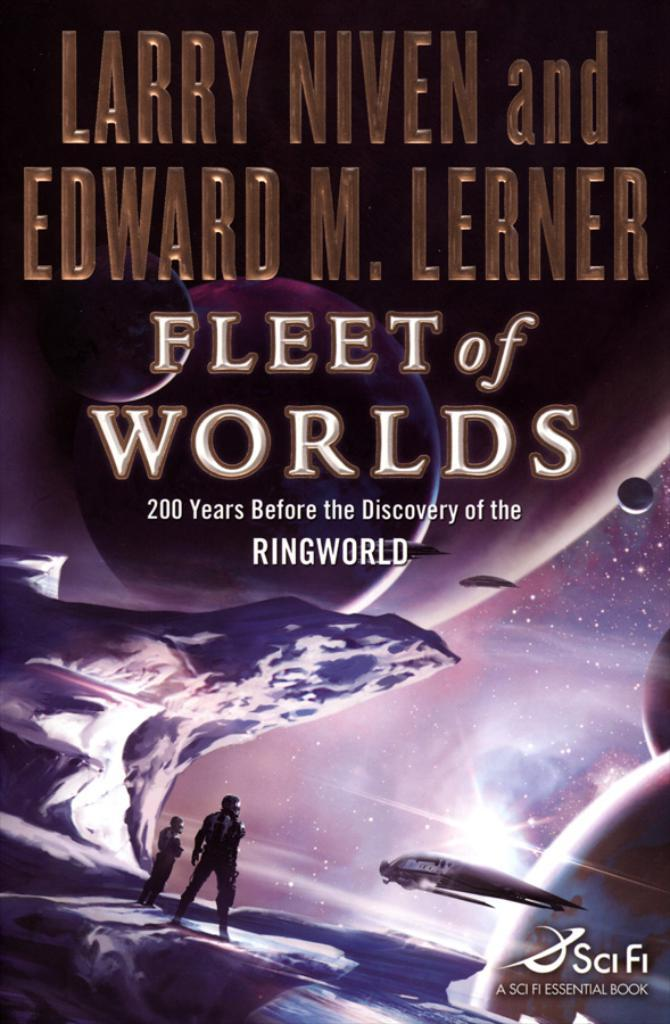<image>
Share a concise interpretation of the image provided. The cover of the book Fleet of Worlds 